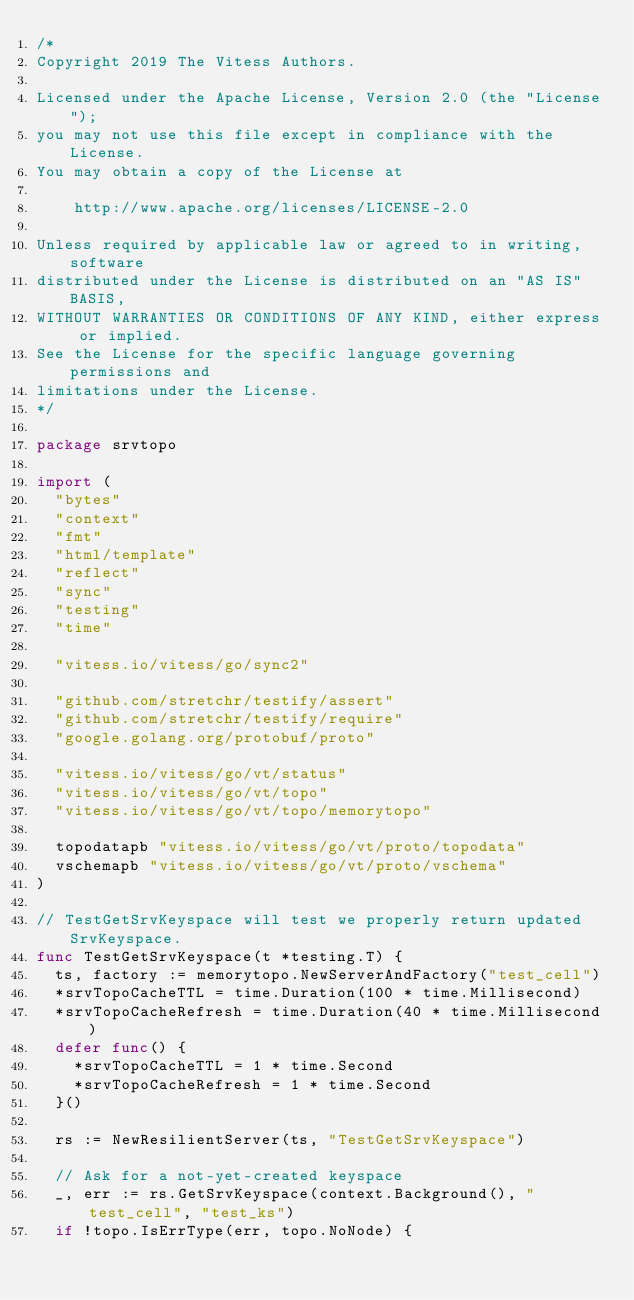<code> <loc_0><loc_0><loc_500><loc_500><_Go_>/*
Copyright 2019 The Vitess Authors.

Licensed under the Apache License, Version 2.0 (the "License");
you may not use this file except in compliance with the License.
You may obtain a copy of the License at

    http://www.apache.org/licenses/LICENSE-2.0

Unless required by applicable law or agreed to in writing, software
distributed under the License is distributed on an "AS IS" BASIS,
WITHOUT WARRANTIES OR CONDITIONS OF ANY KIND, either express or implied.
See the License for the specific language governing permissions and
limitations under the License.
*/

package srvtopo

import (
	"bytes"
	"context"
	"fmt"
	"html/template"
	"reflect"
	"sync"
	"testing"
	"time"

	"vitess.io/vitess/go/sync2"

	"github.com/stretchr/testify/assert"
	"github.com/stretchr/testify/require"
	"google.golang.org/protobuf/proto"

	"vitess.io/vitess/go/vt/status"
	"vitess.io/vitess/go/vt/topo"
	"vitess.io/vitess/go/vt/topo/memorytopo"

	topodatapb "vitess.io/vitess/go/vt/proto/topodata"
	vschemapb "vitess.io/vitess/go/vt/proto/vschema"
)

// TestGetSrvKeyspace will test we properly return updated SrvKeyspace.
func TestGetSrvKeyspace(t *testing.T) {
	ts, factory := memorytopo.NewServerAndFactory("test_cell")
	*srvTopoCacheTTL = time.Duration(100 * time.Millisecond)
	*srvTopoCacheRefresh = time.Duration(40 * time.Millisecond)
	defer func() {
		*srvTopoCacheTTL = 1 * time.Second
		*srvTopoCacheRefresh = 1 * time.Second
	}()

	rs := NewResilientServer(ts, "TestGetSrvKeyspace")

	// Ask for a not-yet-created keyspace
	_, err := rs.GetSrvKeyspace(context.Background(), "test_cell", "test_ks")
	if !topo.IsErrType(err, topo.NoNode) {</code> 